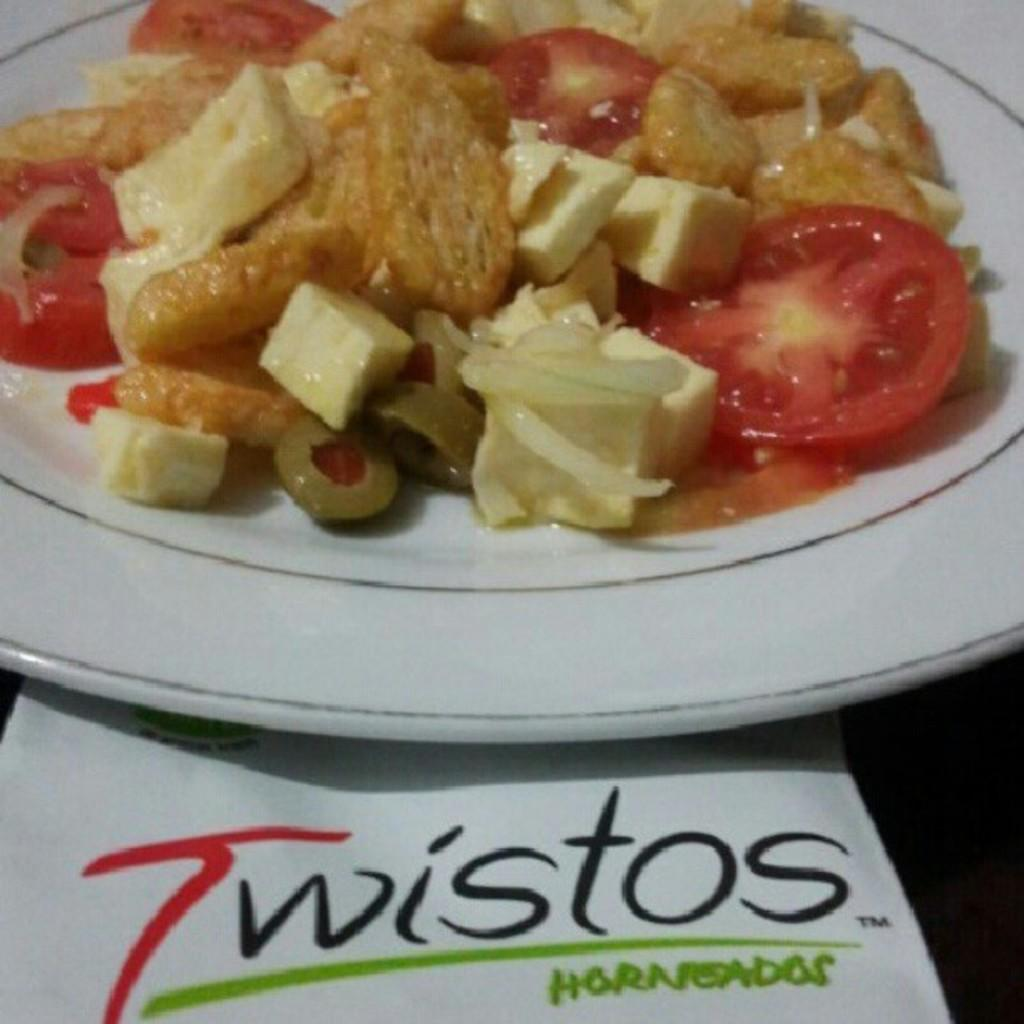What is the color of the plate that holds the food item in the image? The plate is white in color. What is the food item placed on the plate? The facts do not specify the type of food item on the plate. What is written on the white color paper in the image? The facts do not specify the content of the text written on the paper. Is the maid in the image holding a bead while stopping the food from falling off the plate? There is no maid or bead present in the image. The image only shows a food item on a white color plate and a text written on a white color paper. 